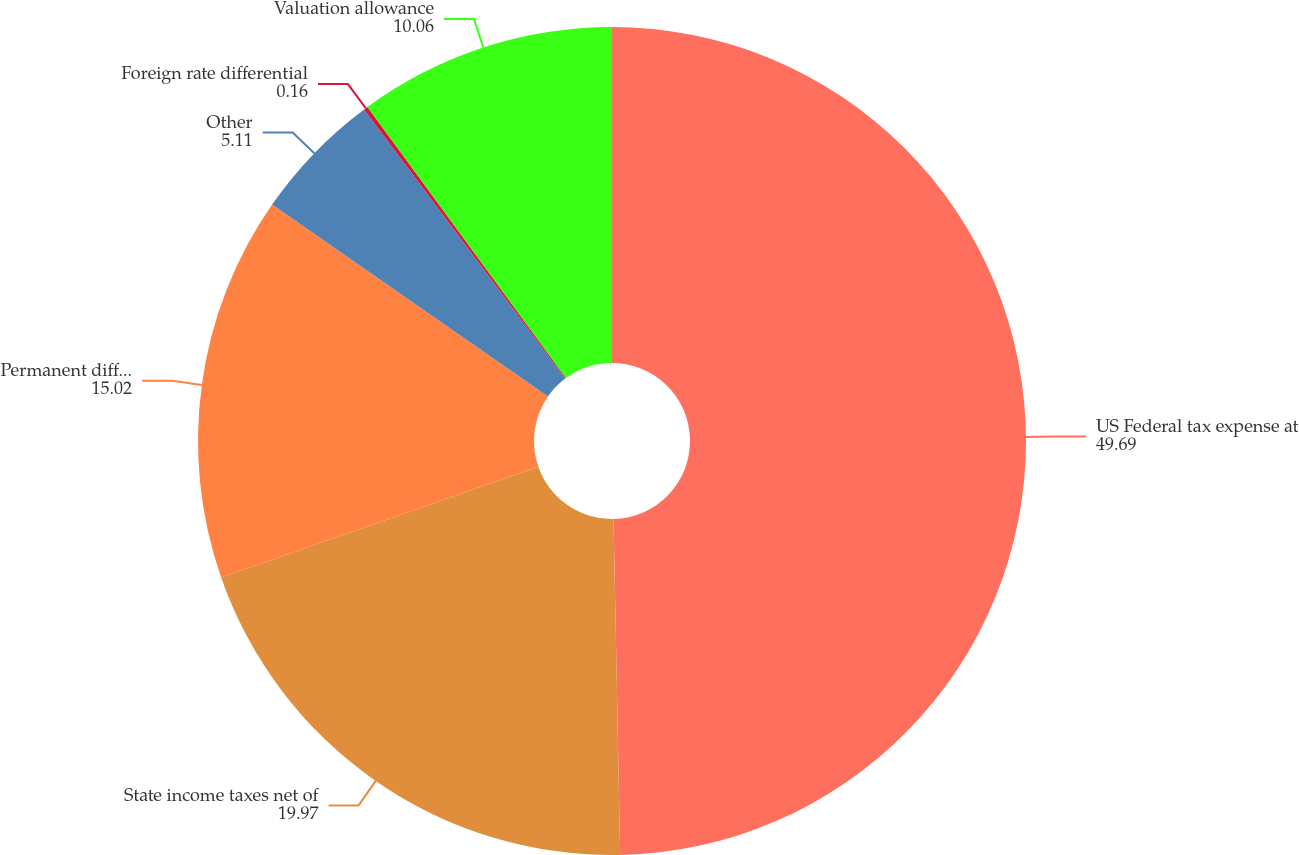<chart> <loc_0><loc_0><loc_500><loc_500><pie_chart><fcel>US Federal tax expense at<fcel>State income taxes net of<fcel>Permanent differences<fcel>Other<fcel>Foreign rate differential<fcel>Valuation allowance<nl><fcel>49.69%<fcel>19.97%<fcel>15.02%<fcel>5.11%<fcel>0.16%<fcel>10.06%<nl></chart> 